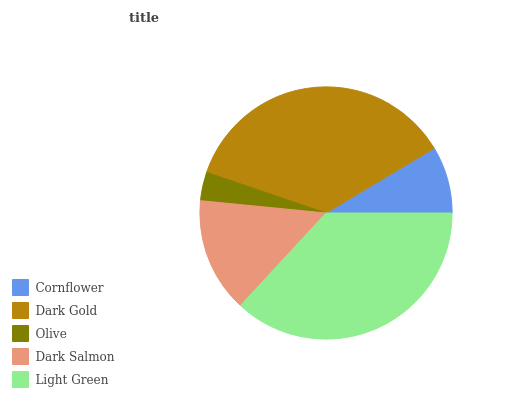Is Olive the minimum?
Answer yes or no. Yes. Is Light Green the maximum?
Answer yes or no. Yes. Is Dark Gold the minimum?
Answer yes or no. No. Is Dark Gold the maximum?
Answer yes or no. No. Is Dark Gold greater than Cornflower?
Answer yes or no. Yes. Is Cornflower less than Dark Gold?
Answer yes or no. Yes. Is Cornflower greater than Dark Gold?
Answer yes or no. No. Is Dark Gold less than Cornflower?
Answer yes or no. No. Is Dark Salmon the high median?
Answer yes or no. Yes. Is Dark Salmon the low median?
Answer yes or no. Yes. Is Cornflower the high median?
Answer yes or no. No. Is Dark Gold the low median?
Answer yes or no. No. 